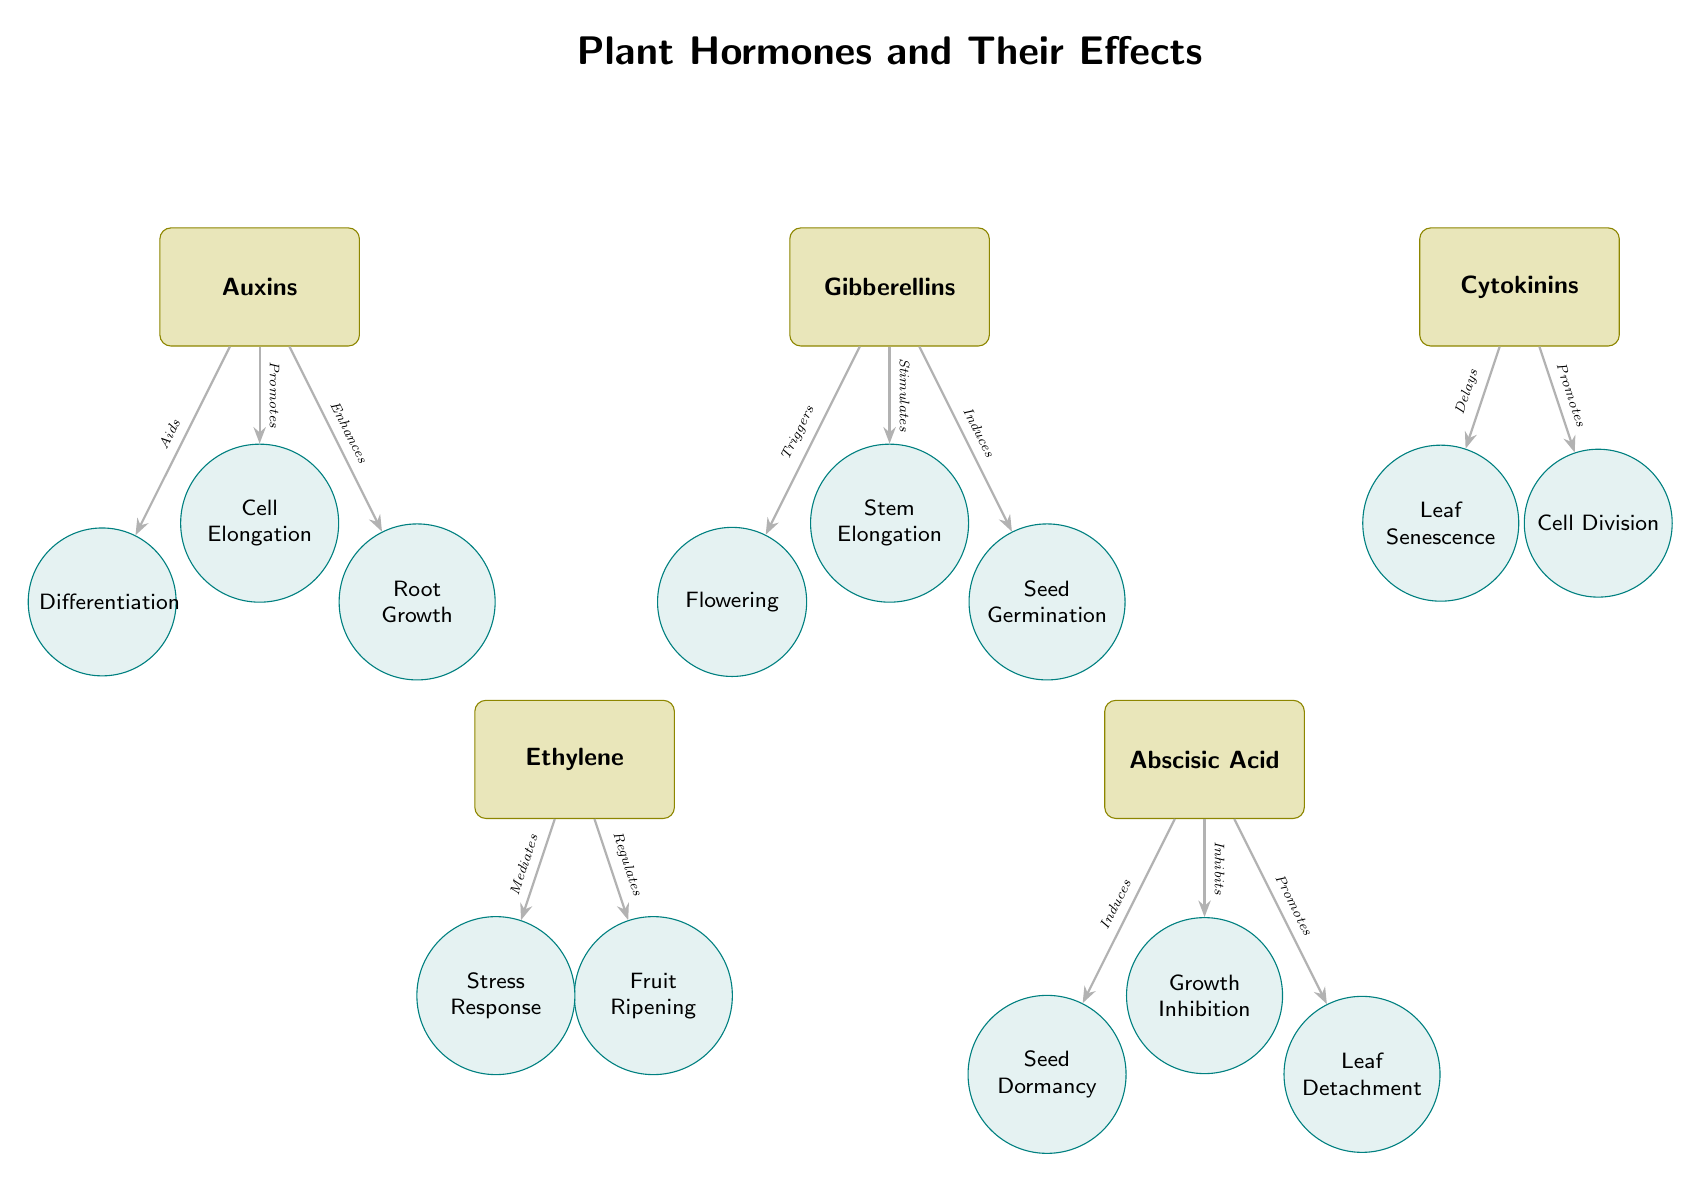What hormone is responsible for cell elongation? According to the diagram, auxins are connected with a direct arrow to the effect of cell elongation, indicating it as a function of auxins.
Answer: Auxins What effect does gibberellins trigger in plants? The diagram shows a direct connection from gibberellins to flowering, indicating that one of its effects is to trigger flowering.
Answer: Flowering How many main plant hormones are depicted in the diagram? The diagram lists five distinct hormones at the top, which include auxins, gibberellins, cytokinins, ethylene, and abscisic acid. Counting these gives the total number of main hormones.
Answer: 5 Which hormone promotes leaf detachment? The diagram connects the hormone abscisic acid to the effect of leaf detachment, indicating that this hormone promotes that effect.
Answer: Abscisic Acid What effect is specifically associated with ethylene concerning environmental response? Ethylene is shown to mediate stress response in the diagram, indicating a specific role of ethylene in that context.
Answer: Stress Response Which hormone inhibits growth? The diagram indicates that abscisic acid has an arrow leading to growth inhibition, meaning that it is the hormone responsible for inhibiting growth.
Answer: Abscisic Acid That hormone promotes root growth? Auxins are depicted with a connection to the root growth effect, signifying their role in promoting this specific growth aspect.
Answer: Auxins What effect is linked to cytokinins besides cell division? The diagram shows that cytokinins are connected to the effect of delaying leaf senescence, which is another effect associated with this hormone.
Answer: Leaf Senescence 